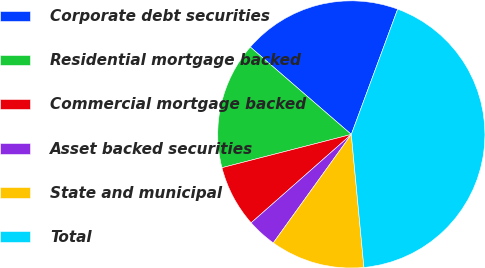Convert chart. <chart><loc_0><loc_0><loc_500><loc_500><pie_chart><fcel>Corporate debt securities<fcel>Residential mortgage backed<fcel>Commercial mortgage backed<fcel>Asset backed securities<fcel>State and municipal<fcel>Total<nl><fcel>19.29%<fcel>15.36%<fcel>7.5%<fcel>3.57%<fcel>11.43%<fcel>42.86%<nl></chart> 